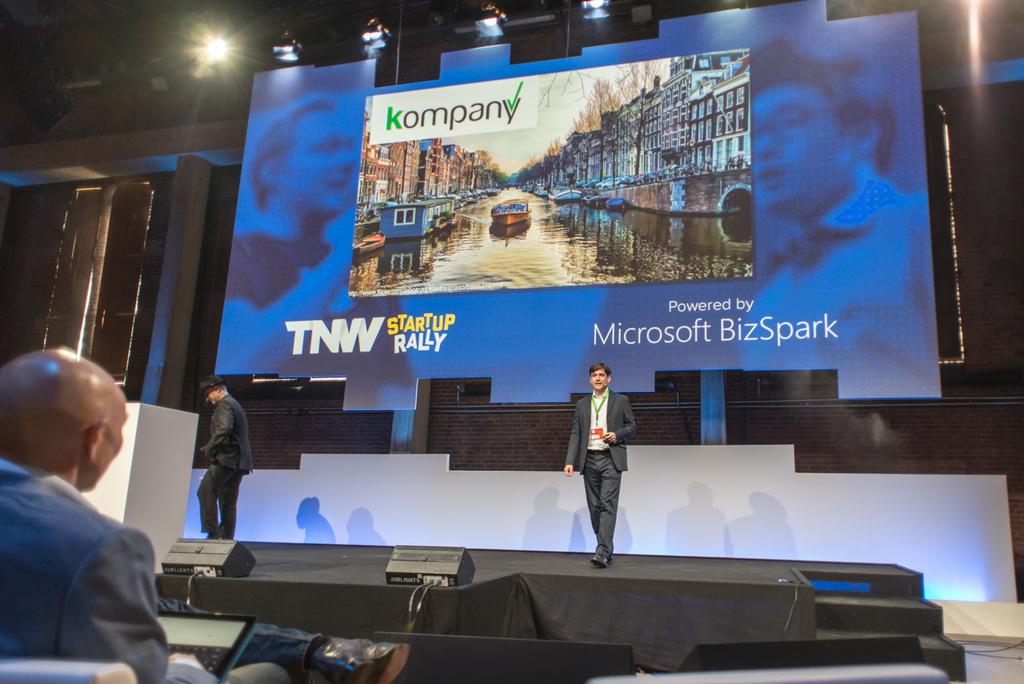What is the speaker's presentation about?
Provide a succinct answer. Kompany. Who is this presentation powered by?
Your answer should be compact. Microsoft bizspark. 